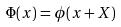<formula> <loc_0><loc_0><loc_500><loc_500>\Phi ( x ) = \phi ( x + X )</formula> 